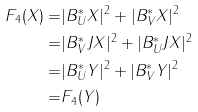Convert formula to latex. <formula><loc_0><loc_0><loc_500><loc_500>F _ { 4 } ( X ) = & | B ^ { * } _ { U } X | ^ { 2 } + | B ^ { * } _ { V } X | ^ { 2 } \\ = & | B ^ { * } _ { V } J X | ^ { 2 } + | B ^ { * } _ { U } J X | ^ { 2 } \\ = & | B ^ { * } _ { U } Y | ^ { 2 } + | B ^ { * } _ { V } Y | ^ { 2 } \\ = & F _ { 4 } ( Y )</formula> 